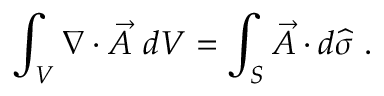Convert formula to latex. <formula><loc_0><loc_0><loc_500><loc_500>\int _ { V } \nabla \cdot { \vec { A } } \ d V = \int _ { S } { \vec { A } } \cdot d { \widehat { \sigma } } .</formula> 